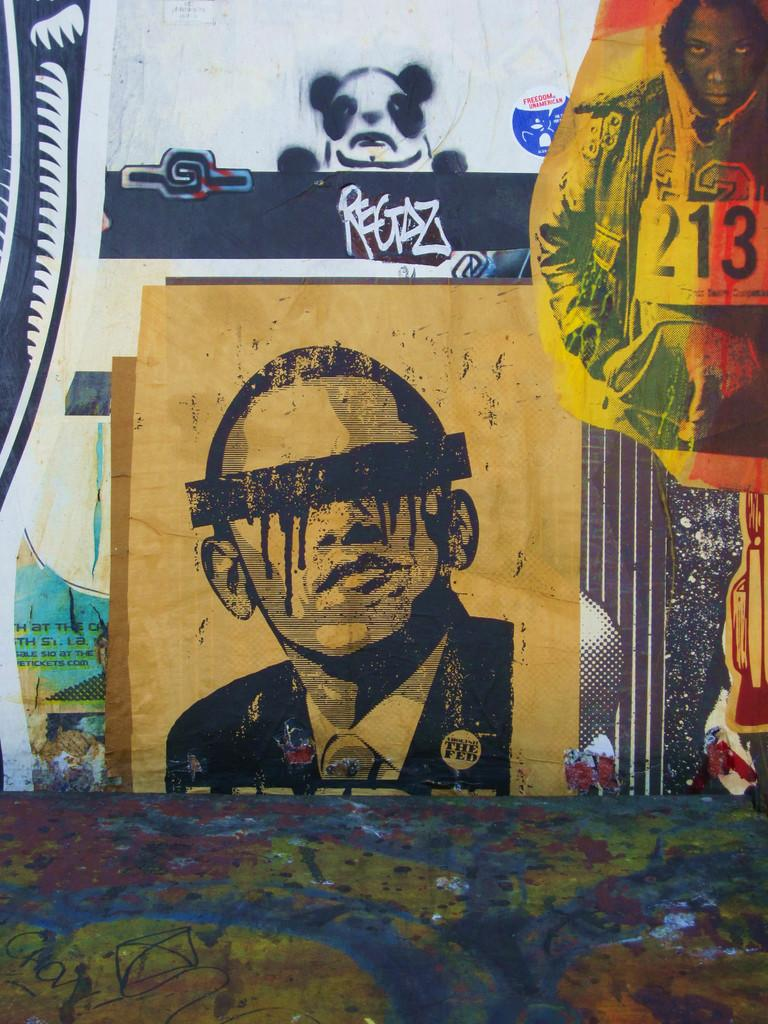<image>
Summarize the visual content of the image. A portrait of Barrack O'bama wearing a "The Fed" pin on his lapel. 